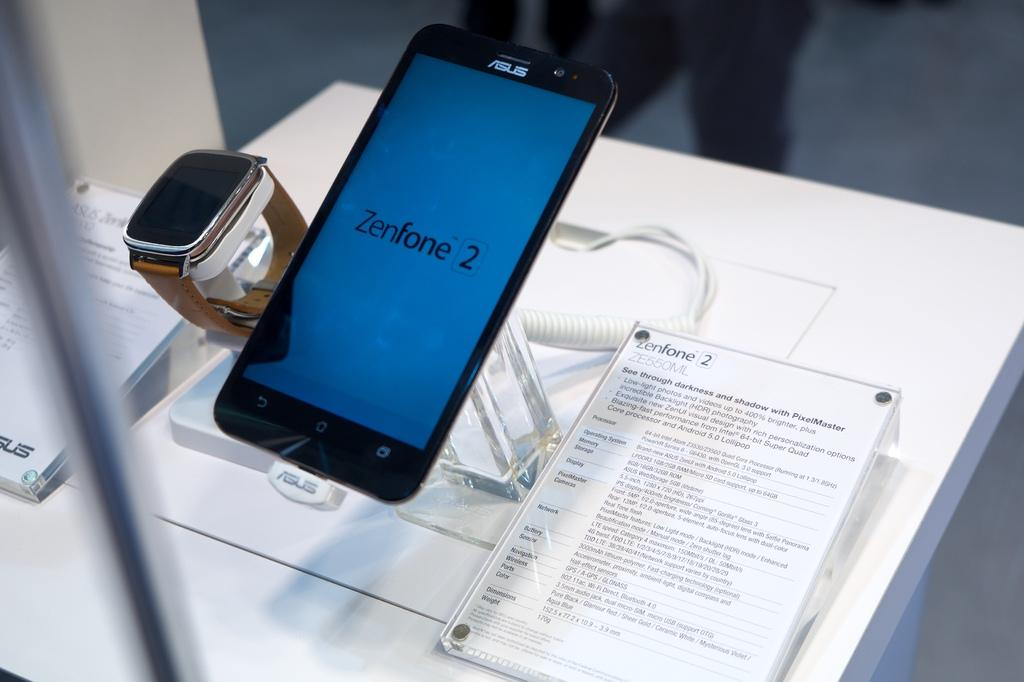Provide a one-sentence caption for the provided image. Sign for a phone which says "Zenfone 2" on it. 